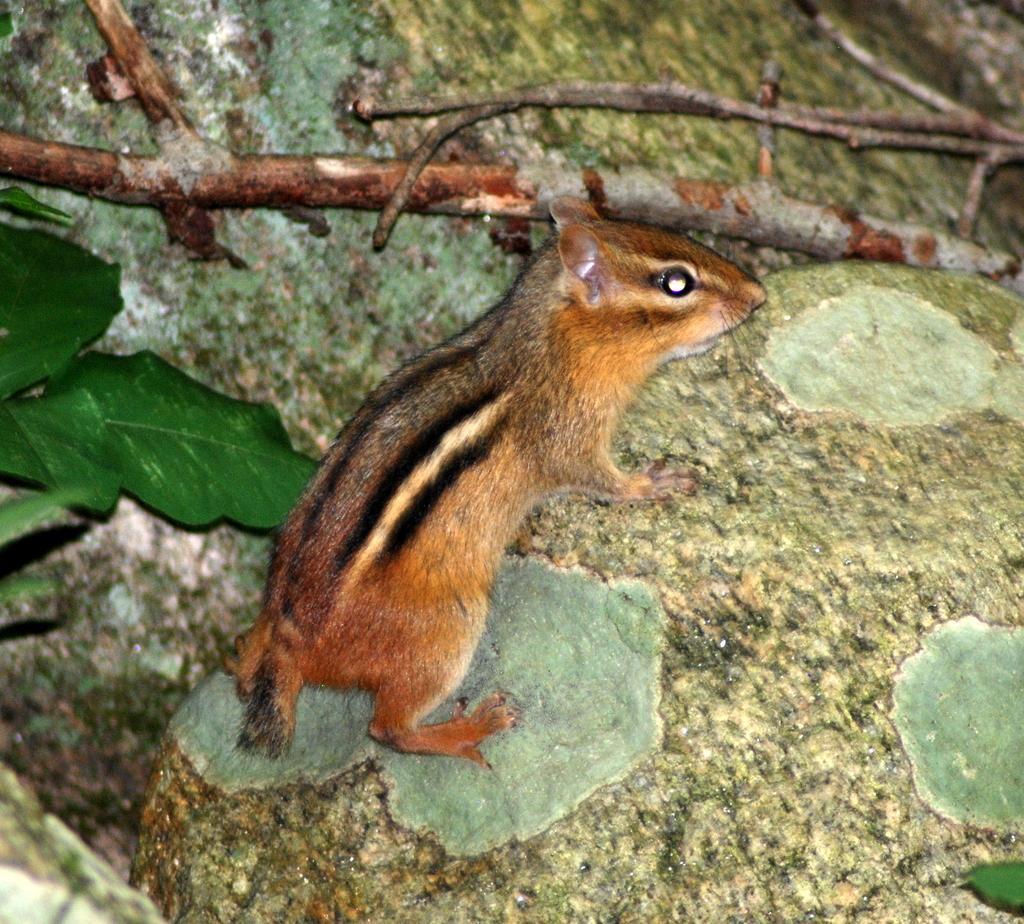In one or two sentences, can you explain what this image depicts? In this image I can see a brown colour squirrel, few sticks and few green colour leaves. 